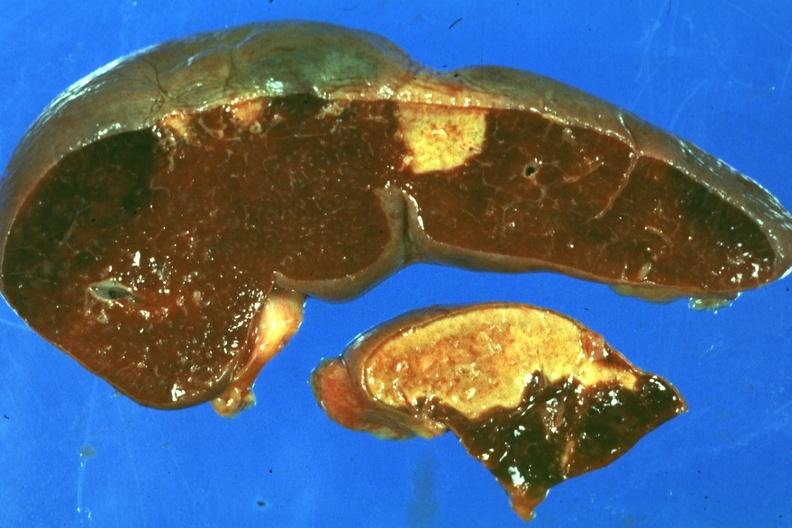what is present?
Answer the question using a single word or phrase. Spleen 